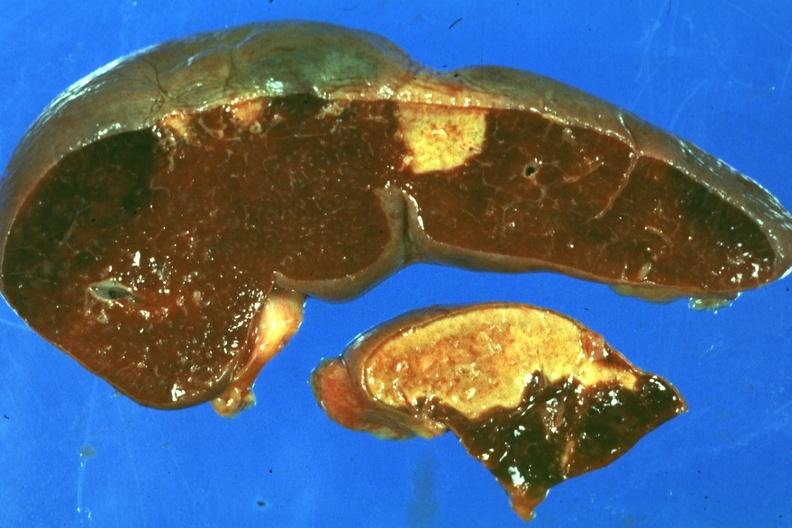what is present?
Answer the question using a single word or phrase. Spleen 